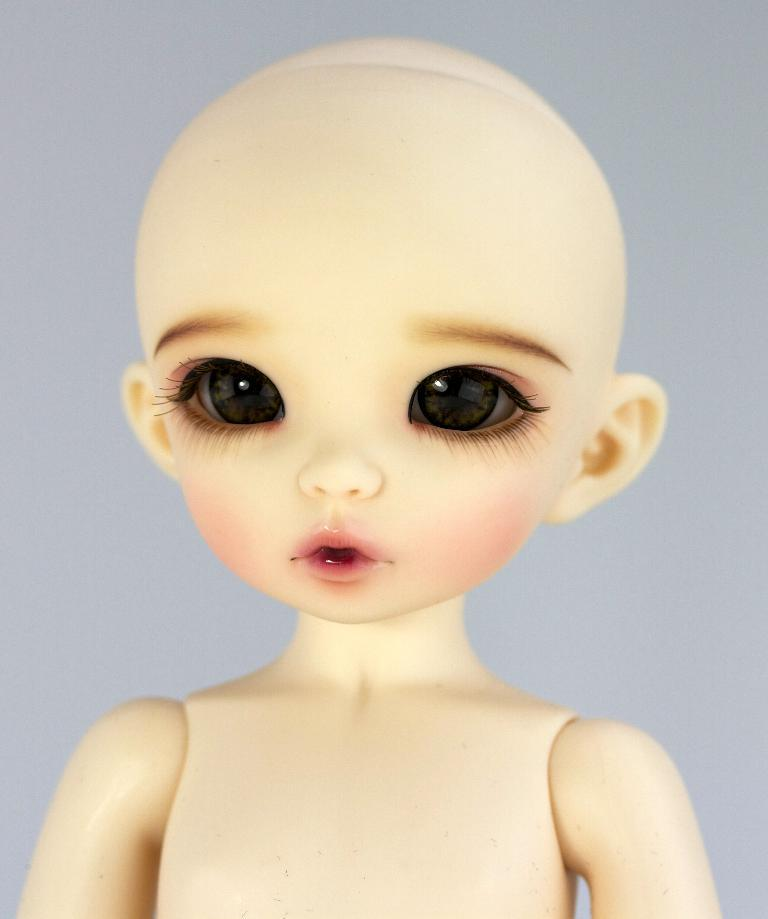What is the main subject of the image? There is a doll in the image. What color is the background of the image? The background of the image is white. What type of wire is being used to hold the seed in the image? There is no wire or seed present in the image; it only features a doll against a white background. 